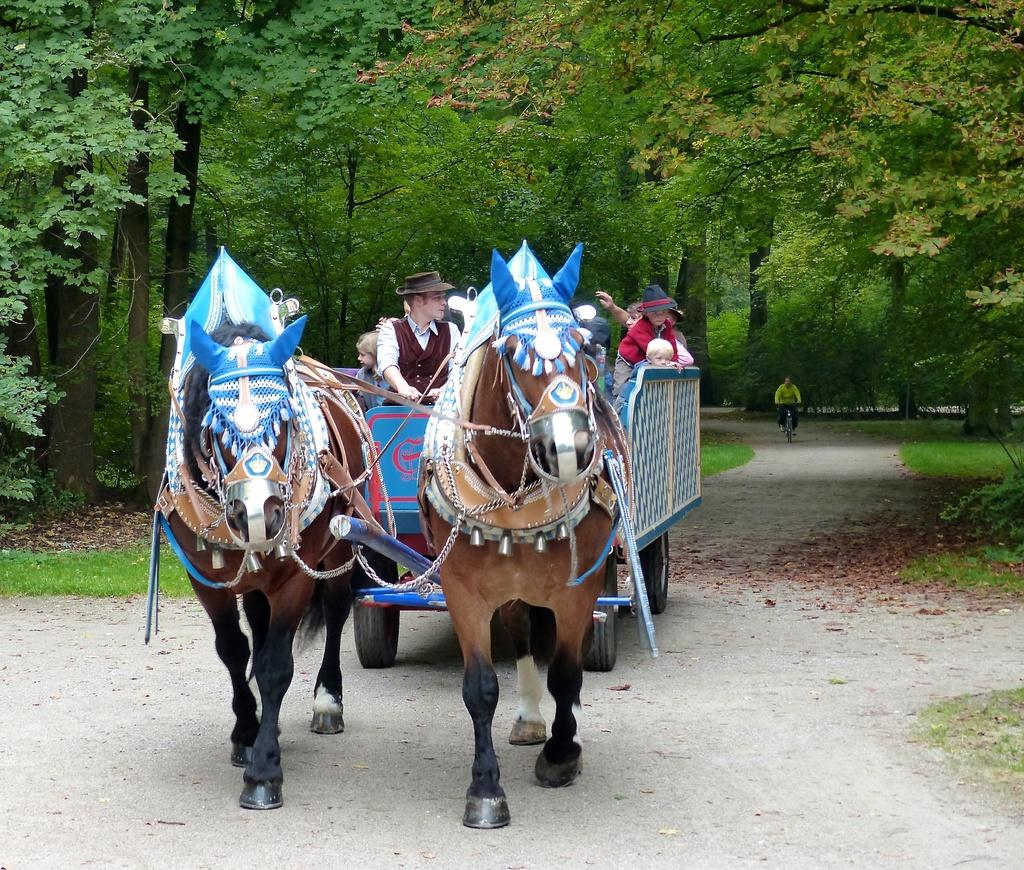What type of vehicle is in the image? There is a horse-drawn carriage (tanga) in the image. Who is riding the horse-drawn carriage? There are people sitting on the horse-drawn carriage. What other mode of transportation can be seen in the image? There is a man riding a bicycle in the image. What type of landscape is visible in the image? The trees are on a grassland. What degree does the horse have in the image? There is no horse in the image, only a horse-drawn carriage. Additionally, degrees are not applicable to animals. 